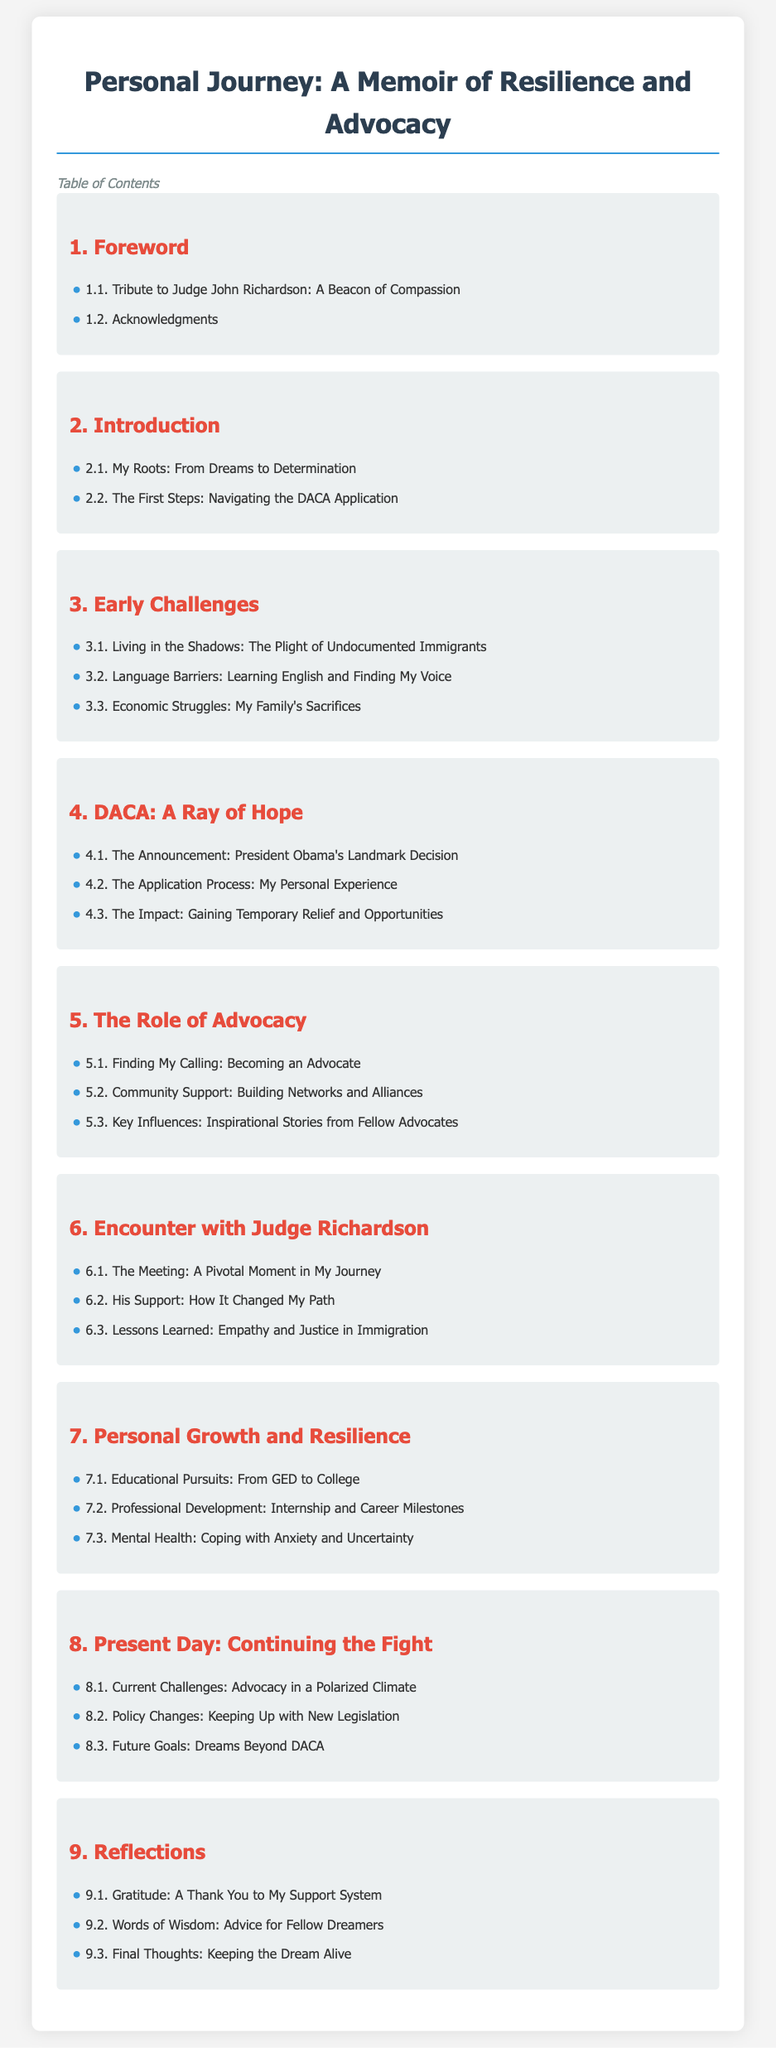what is the title of the memoir? The title is the main heading of the document, which is stated at the top.
Answer: Personal Journey: A Memoir of Resilience and Advocacy who is the retired immigration judge mentioned in the foreword? The judge's name is mentioned in the first section of the document, specifically in the tribute.
Answer: Judge John Richardson how many chapters are in the Table of Contents? The number of chapters can be counted from the list provided in the document.
Answer: 9 what is the main theme of chapter 4? The title of chapter 4 indicates its focus on a specific topic, revealing its intent.
Answer: DACA: A Ray of Hope which chapter discusses personal growth? The chapter number can be found by looking at the headings within the Table of Contents.
Answer: 7 